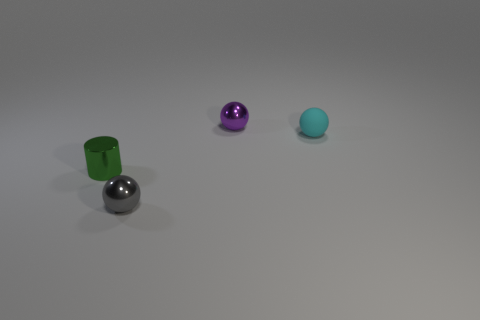What is the size of the shiny thing behind the tiny ball that is to the right of the metallic sphere that is behind the gray metal object?
Offer a terse response. Small. Is the number of tiny purple rubber blocks greater than the number of gray shiny objects?
Offer a terse response. No. There is a tiny ball that is right of the purple shiny object; is it the same color as the metal object behind the small green metal cylinder?
Offer a very short reply. No. Is the small sphere that is right of the purple thing made of the same material as the small ball that is behind the matte object?
Your response must be concise. No. How many other objects are the same size as the cyan rubber thing?
Ensure brevity in your answer.  3. Are there fewer green shiny cylinders than tiny cyan metal blocks?
Make the answer very short. No. There is a thing that is right of the tiny metal sphere that is behind the small cyan rubber object; what is its shape?
Your answer should be very brief. Sphere. There is a purple thing that is the same size as the gray object; what is its shape?
Make the answer very short. Sphere. Is there another tiny matte thing of the same shape as the cyan thing?
Your response must be concise. No. What is the tiny green cylinder made of?
Your response must be concise. Metal. 